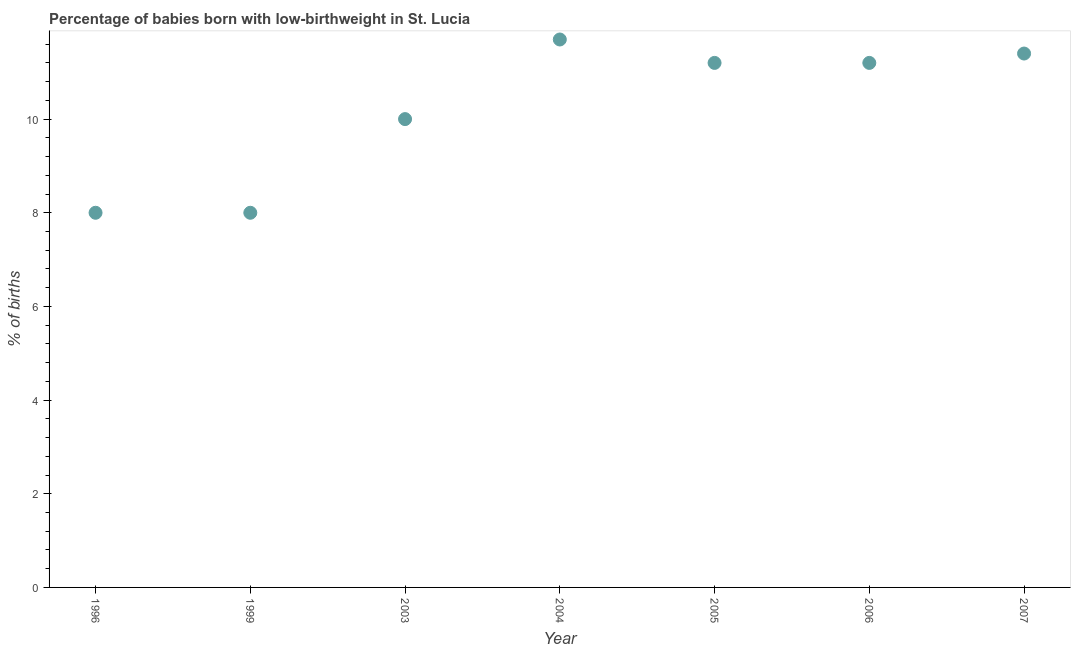Across all years, what is the maximum percentage of babies who were born with low-birthweight?
Provide a succinct answer. 11.7. What is the sum of the percentage of babies who were born with low-birthweight?
Provide a short and direct response. 71.5. What is the difference between the percentage of babies who were born with low-birthweight in 2004 and 2006?
Make the answer very short. 0.5. What is the average percentage of babies who were born with low-birthweight per year?
Offer a very short reply. 10.21. In how many years, is the percentage of babies who were born with low-birthweight greater than 10 %?
Your answer should be compact. 4. What is the ratio of the percentage of babies who were born with low-birthweight in 2003 to that in 2007?
Keep it short and to the point. 0.88. What is the difference between the highest and the second highest percentage of babies who were born with low-birthweight?
Your answer should be compact. 0.3. What is the difference between the highest and the lowest percentage of babies who were born with low-birthweight?
Ensure brevity in your answer.  3.7. Does the percentage of babies who were born with low-birthweight monotonically increase over the years?
Provide a succinct answer. No. How many years are there in the graph?
Your answer should be very brief. 7. What is the difference between two consecutive major ticks on the Y-axis?
Your response must be concise. 2. Does the graph contain any zero values?
Provide a succinct answer. No. What is the title of the graph?
Ensure brevity in your answer.  Percentage of babies born with low-birthweight in St. Lucia. What is the label or title of the X-axis?
Your answer should be compact. Year. What is the label or title of the Y-axis?
Provide a succinct answer. % of births. What is the % of births in 2003?
Make the answer very short. 10. What is the % of births in 2004?
Your response must be concise. 11.7. What is the difference between the % of births in 1996 and 1999?
Offer a terse response. 0. What is the difference between the % of births in 1996 and 2003?
Provide a succinct answer. -2. What is the difference between the % of births in 1996 and 2004?
Offer a terse response. -3.7. What is the difference between the % of births in 1996 and 2006?
Your response must be concise. -3.2. What is the difference between the % of births in 1996 and 2007?
Make the answer very short. -3.4. What is the difference between the % of births in 1999 and 2003?
Make the answer very short. -2. What is the difference between the % of births in 1999 and 2004?
Keep it short and to the point. -3.7. What is the difference between the % of births in 1999 and 2006?
Your answer should be very brief. -3.2. What is the difference between the % of births in 1999 and 2007?
Your answer should be very brief. -3.4. What is the difference between the % of births in 2003 and 2006?
Give a very brief answer. -1.2. What is the difference between the % of births in 2004 and 2006?
Give a very brief answer. 0.5. What is the difference between the % of births in 2004 and 2007?
Offer a terse response. 0.3. What is the difference between the % of births in 2006 and 2007?
Your response must be concise. -0.2. What is the ratio of the % of births in 1996 to that in 2003?
Your answer should be very brief. 0.8. What is the ratio of the % of births in 1996 to that in 2004?
Give a very brief answer. 0.68. What is the ratio of the % of births in 1996 to that in 2005?
Offer a terse response. 0.71. What is the ratio of the % of births in 1996 to that in 2006?
Keep it short and to the point. 0.71. What is the ratio of the % of births in 1996 to that in 2007?
Ensure brevity in your answer.  0.7. What is the ratio of the % of births in 1999 to that in 2004?
Provide a short and direct response. 0.68. What is the ratio of the % of births in 1999 to that in 2005?
Your response must be concise. 0.71. What is the ratio of the % of births in 1999 to that in 2006?
Your answer should be compact. 0.71. What is the ratio of the % of births in 1999 to that in 2007?
Your answer should be compact. 0.7. What is the ratio of the % of births in 2003 to that in 2004?
Your answer should be very brief. 0.85. What is the ratio of the % of births in 2003 to that in 2005?
Your response must be concise. 0.89. What is the ratio of the % of births in 2003 to that in 2006?
Make the answer very short. 0.89. What is the ratio of the % of births in 2003 to that in 2007?
Your answer should be compact. 0.88. What is the ratio of the % of births in 2004 to that in 2005?
Offer a terse response. 1.04. What is the ratio of the % of births in 2004 to that in 2006?
Provide a succinct answer. 1.04. What is the ratio of the % of births in 2004 to that in 2007?
Offer a very short reply. 1.03. What is the ratio of the % of births in 2005 to that in 2006?
Provide a succinct answer. 1. 